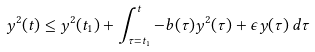<formula> <loc_0><loc_0><loc_500><loc_500>y ^ { 2 } ( t ) \leq y ^ { 2 } ( t _ { 1 } ) + \int _ { \tau = t _ { 1 } } ^ { t } - b ( \tau ) y ^ { 2 } ( \tau ) + \epsilon y ( \tau ) \, d \tau</formula> 